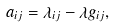<formula> <loc_0><loc_0><loc_500><loc_500>a _ { i j } = \lambda _ { i j } - \lambda g _ { i j } ,</formula> 